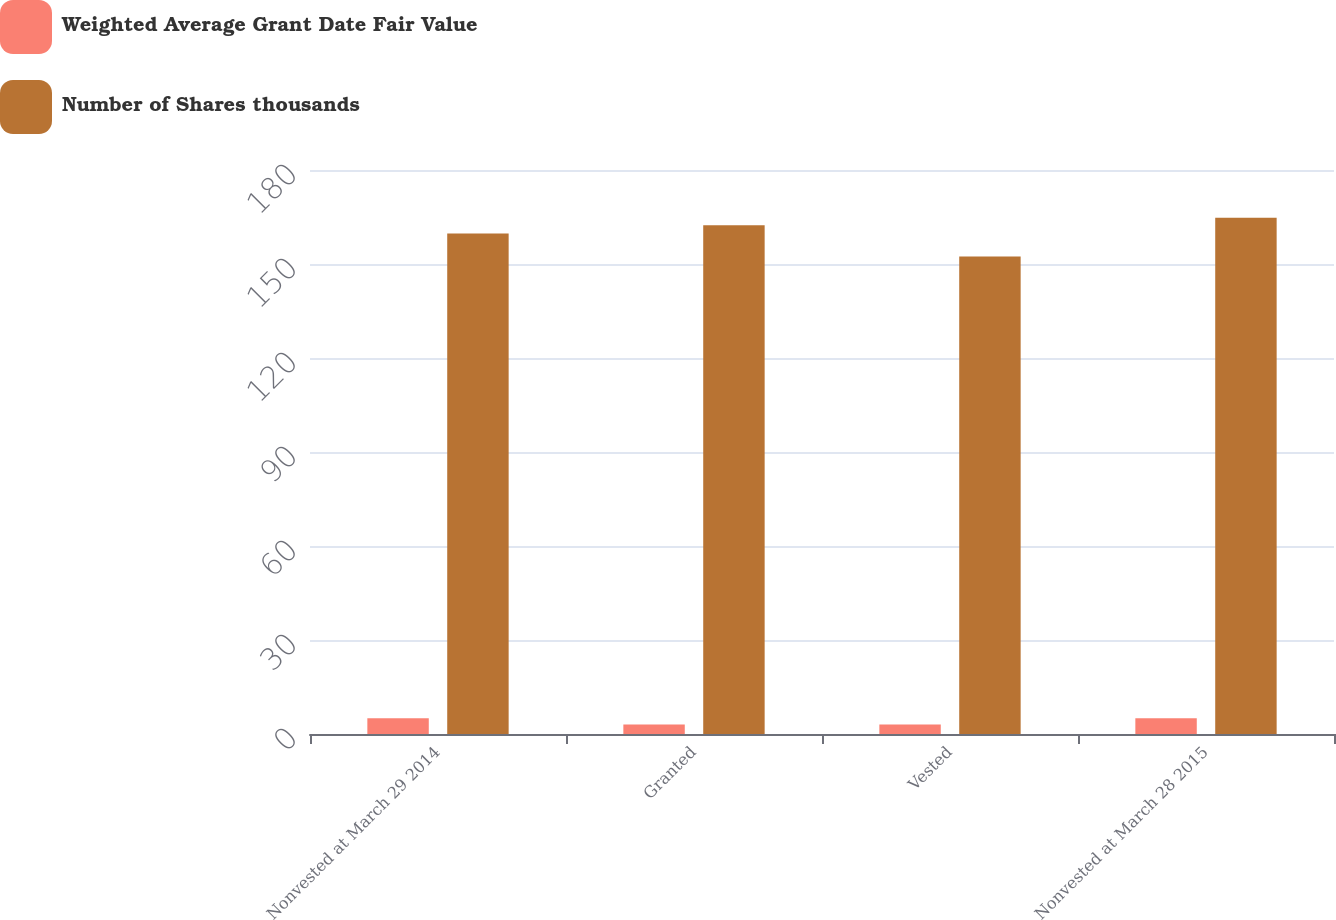<chart> <loc_0><loc_0><loc_500><loc_500><stacked_bar_chart><ecel><fcel>Nonvested at March 29 2014<fcel>Granted<fcel>Vested<fcel>Nonvested at March 28 2015<nl><fcel>Weighted Average Grant Date Fair Value<fcel>5<fcel>3<fcel>3<fcel>5<nl><fcel>Number of Shares thousands<fcel>159.71<fcel>162.36<fcel>152.4<fcel>164.73<nl></chart> 